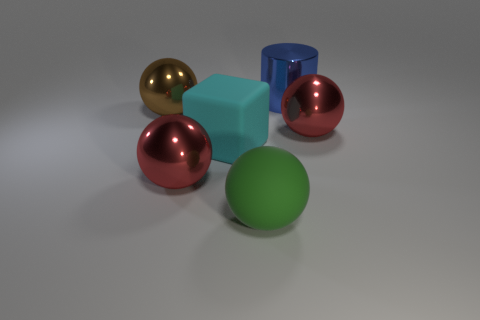Subtract all large shiny spheres. How many spheres are left? 1 Add 3 brown rubber balls. How many objects exist? 9 Subtract 1 cylinders. How many cylinders are left? 0 Subtract all gray spheres. Subtract all purple cylinders. How many spheres are left? 4 Subtract all brown cylinders. How many brown balls are left? 1 Subtract all metallic cylinders. Subtract all cyan matte cylinders. How many objects are left? 5 Add 5 big cyan blocks. How many big cyan blocks are left? 6 Add 1 tiny red metallic cubes. How many tiny red metallic cubes exist? 1 Subtract all green balls. How many balls are left? 3 Subtract 0 blue blocks. How many objects are left? 6 